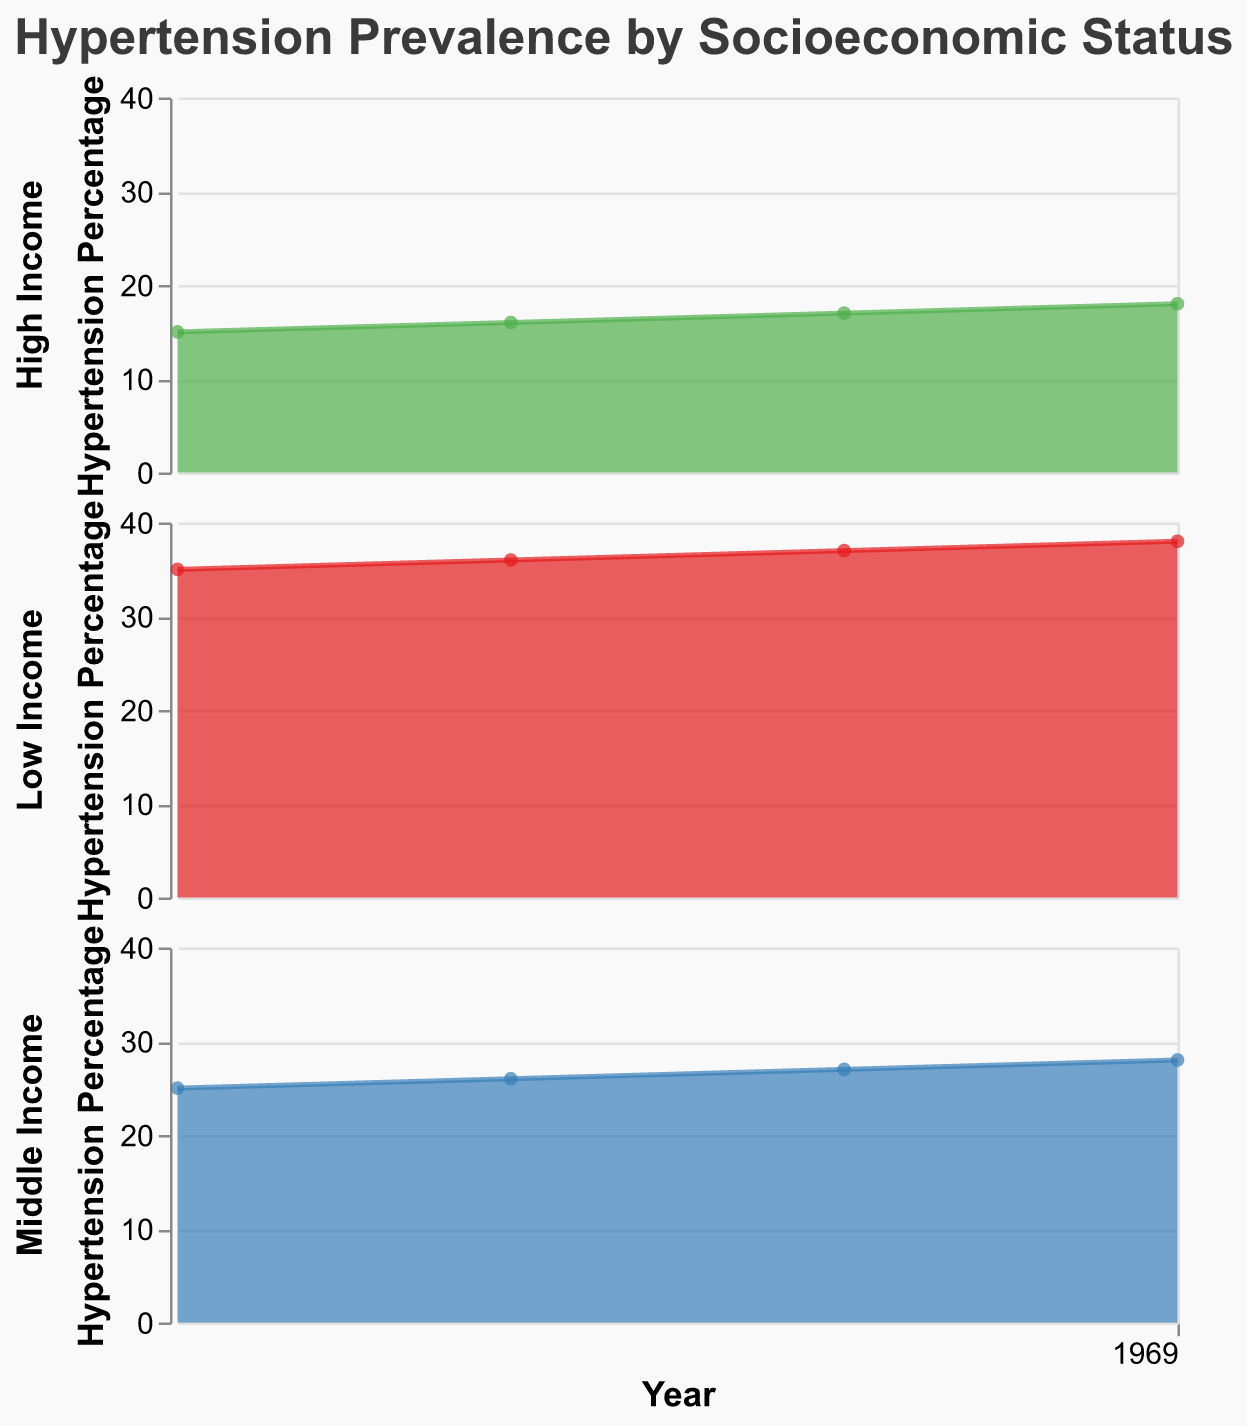What is the title of the figure? The title is usually located at the top of the figure and gives a summary of what the data represents. The given code specifies the title as "Hypertension Prevalence by Socioeconomic Status".
Answer: Hypertension Prevalence by Socioeconomic Status How does the hypertension percentage trend for the low-income group over the years? Observing the plot for the low-income group, the percentage increases each year from 2020 to 2023. The values are 35% in 2020, 36% in 2021, 37% in 2022, and 38% in 2023.
Answer: It increases each year Which socioeconomic status had the lowest hypertension percentage in 2020? The figure shows the hypertension percentages for each socioeconomic status in 2020. The high-income group has the lowest percentage at 15%.
Answer: High Income What is the difference in hypertension percentage between the high-income and low-income groups in 2023? Subtract the hypertension percentage of the high-income group in 2023 (18%) from the low-income group in 2023 (38%). The difference is 38% - 18%.
Answer: 20% Which socioeconomic status shows the highest increase in hypertension percentage from 2020 to 2023? Calculate the increase for each group from 2020 to 2023: 
Low Income: 38% - 35% = 3% 
Middle Income: 28% - 25% = 3% 
High Income: 18% - 15% = 3% 
All groups show an equal increase of 3%.
Answer: All groups show equal increase What is the range of hypertension percentages for the middle-income group across the years displayed? The range is calculated as the difference between the maximum and minimum values observed for the middle-income group. The hypertension percentages are 25% (2020), 26% (2021), 27% (2022), and 28% (2023). The range is 28% - 25%.
Answer: 3% Between which years did the high-income group show no change in hypertension percentage? Look at the hypertension percentages for the high-income group across the years. The figures for 2022 (17%) and 2023 (18%) show a change, so no years exhibit an unchanged percentage.
Answer: No years What pattern can be observed in the hypertension percentage trends of all socioeconomic groups? The percentages for all groups show a consistent increasing trend from 2020 to 2023, with each year having a higher percentage than the previous year. This pattern is evident in all three socioeconomic statuses.
Answer: Increasing trend 